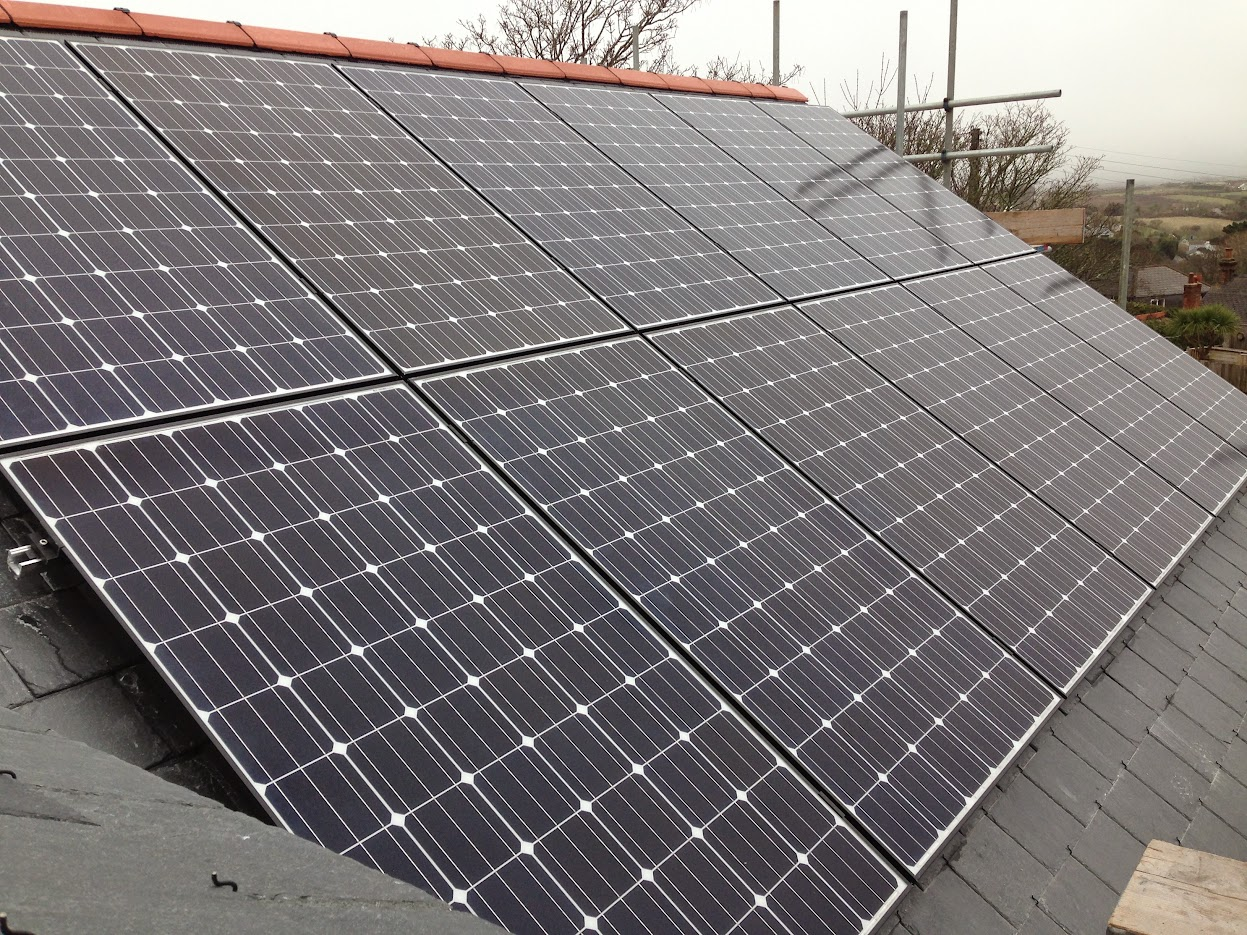How does the positioning of these solar panels affect their efficiency? Solar panel efficiency largely depends on their orientation and angle relative to the sun. Optimal positioning directly facing south at an angle that equals the latitude of the location maximizes sunlight exposure throughout the year, potentially increasing the system's overall effectiveness. 